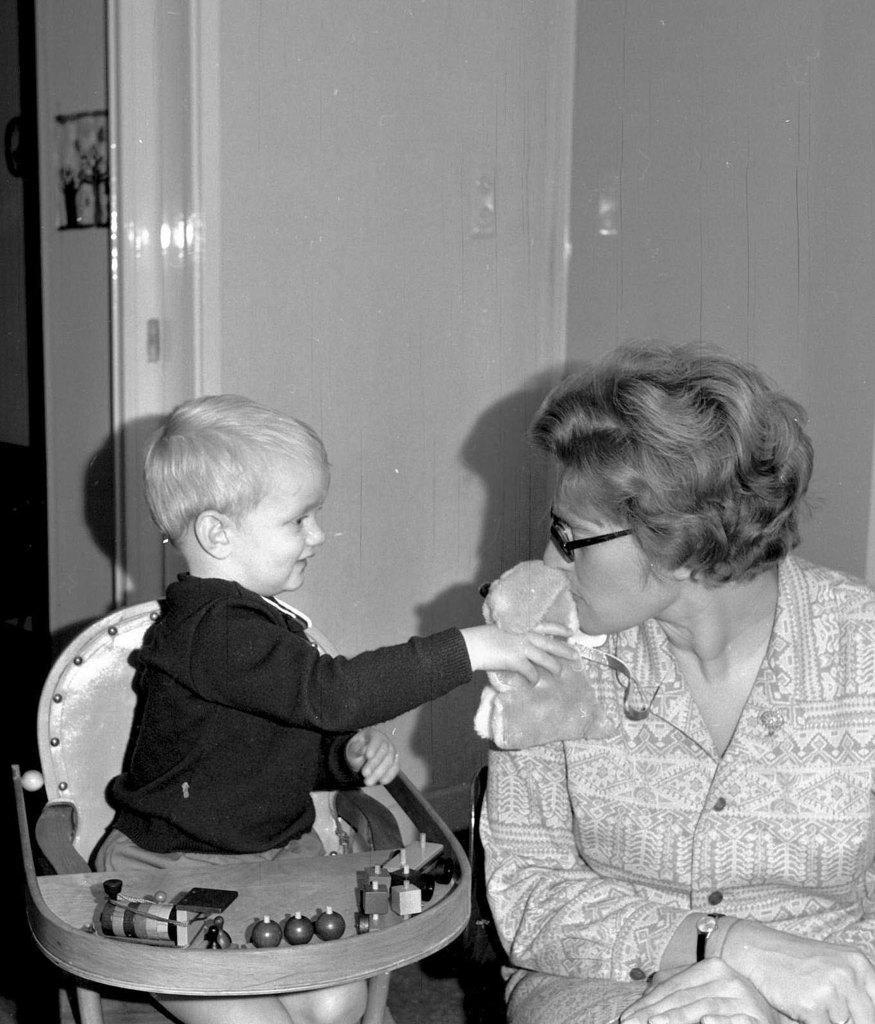Describe this image in one or two sentences. In this picture there is a lady on the right side of the image and there is a baby boy on the left side of the image, inside the walker, by holding a toy in his hand and there is a door in the background area of the image. 